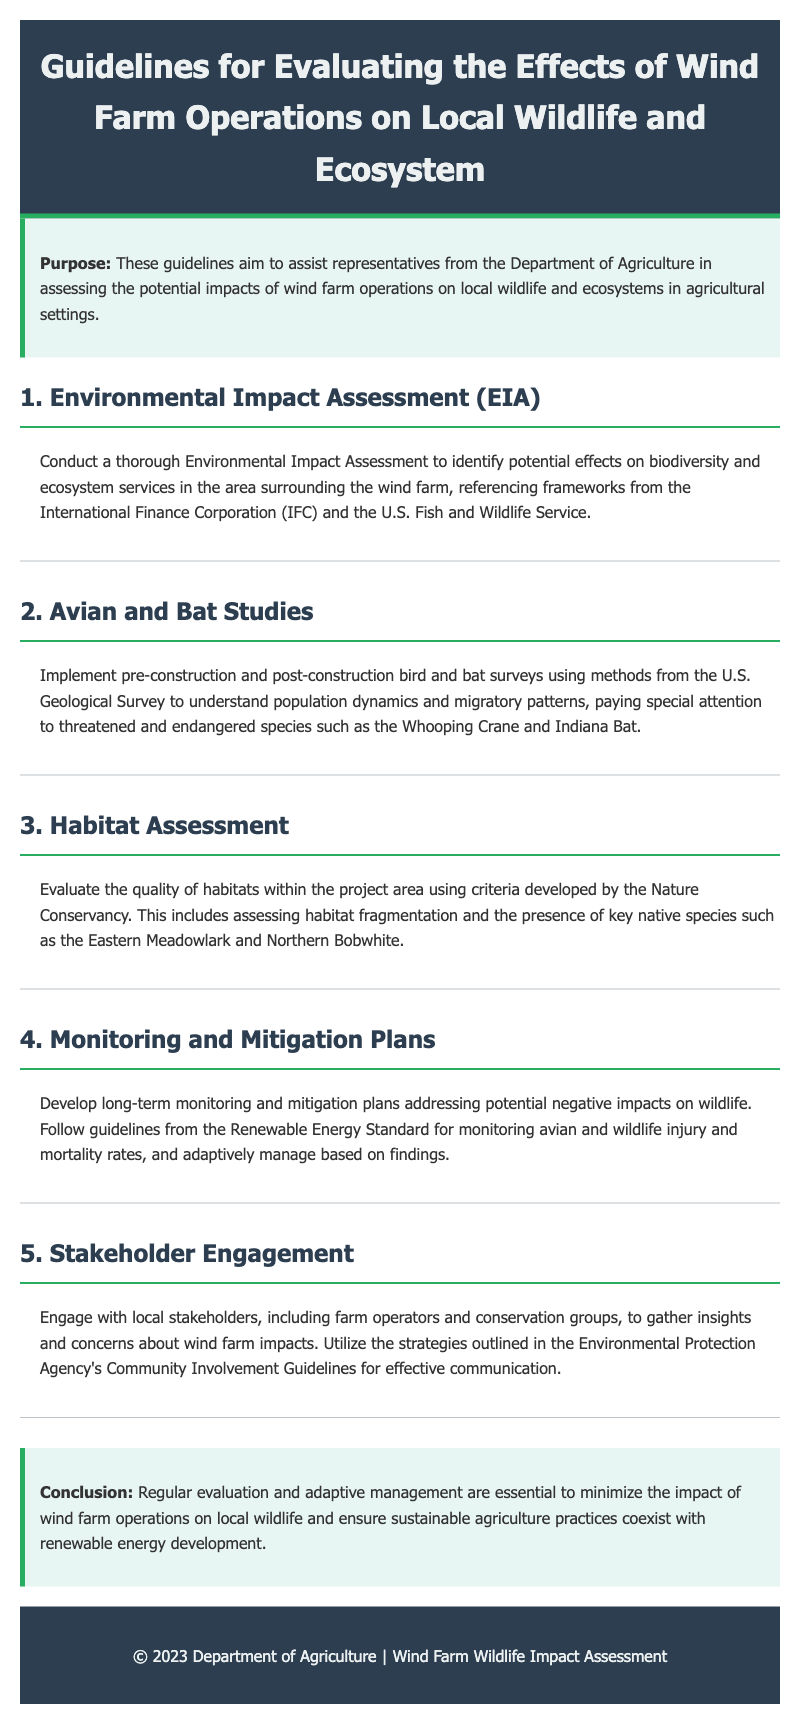What is the purpose of the guidelines? The purpose is to assist representatives from the Department of Agriculture in assessing the potential impacts of wind farm operations on local wildlife and ecosystems in agricultural settings.
Answer: To assist representatives from the Department of Agriculture in assessing impacts What framework should be referenced for Environmental Impact Assessment? The guidelines suggest referencing frameworks from the International Finance Corporation (IFC) and the U.S. Fish and Wildlife Service for the Environmental Impact Assessment.
Answer: International Finance Corporation (IFC) and U.S. Fish and Wildlife Service Which species are specifically mentioned in the Avian and Bat Studies section? The threatened and endangered species mentioned are the Whooping Crane and Indiana Bat, as indicated in the Avian and Bat Studies section.
Answer: Whooping Crane and Indiana Bat What is evaluated in the Habitat Assessment? The quality of habitats within the project area is evaluated, including habitat fragmentation and presence of key native species.
Answer: Quality of habitats and habitat fragmentation What is the conclusion regarding wind farm operations and wildlife? The conclusion emphasizes that regular evaluation and adaptive management are essential to minimize impacts and ensure sustainable agriculture.
Answer: Regular evaluation and adaptive management are essential What should be developed to address potential negative impacts on wildlife? Long-term monitoring and mitigation plans should be developed to address negative impacts on wildlife, according to the guidelines.
Answer: Long-term monitoring and mitigation plans How should stakeholders be engaged according to the guidelines? The guidelines recommend engaging with local stakeholders, including farm operators and conservation groups, to gather insights and concerns.
Answer: Engage with local stakeholders What is the stated relationship between renewable energy development and agriculture? The guidelines highlight the importance of ensuring sustainable agriculture practices coexist with renewable energy development.
Answer: Sustainable agriculture practices coexist with renewable energy development 